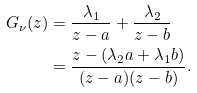<formula> <loc_0><loc_0><loc_500><loc_500>G _ { \nu } ( z ) & = \frac { \lambda _ { 1 } } { z - a } + \frac { \lambda _ { 2 } } { z - b } \\ & = \frac { z - ( \lambda _ { 2 } a + \lambda _ { 1 } b ) } { ( z - a ) ( z - b ) } .</formula> 